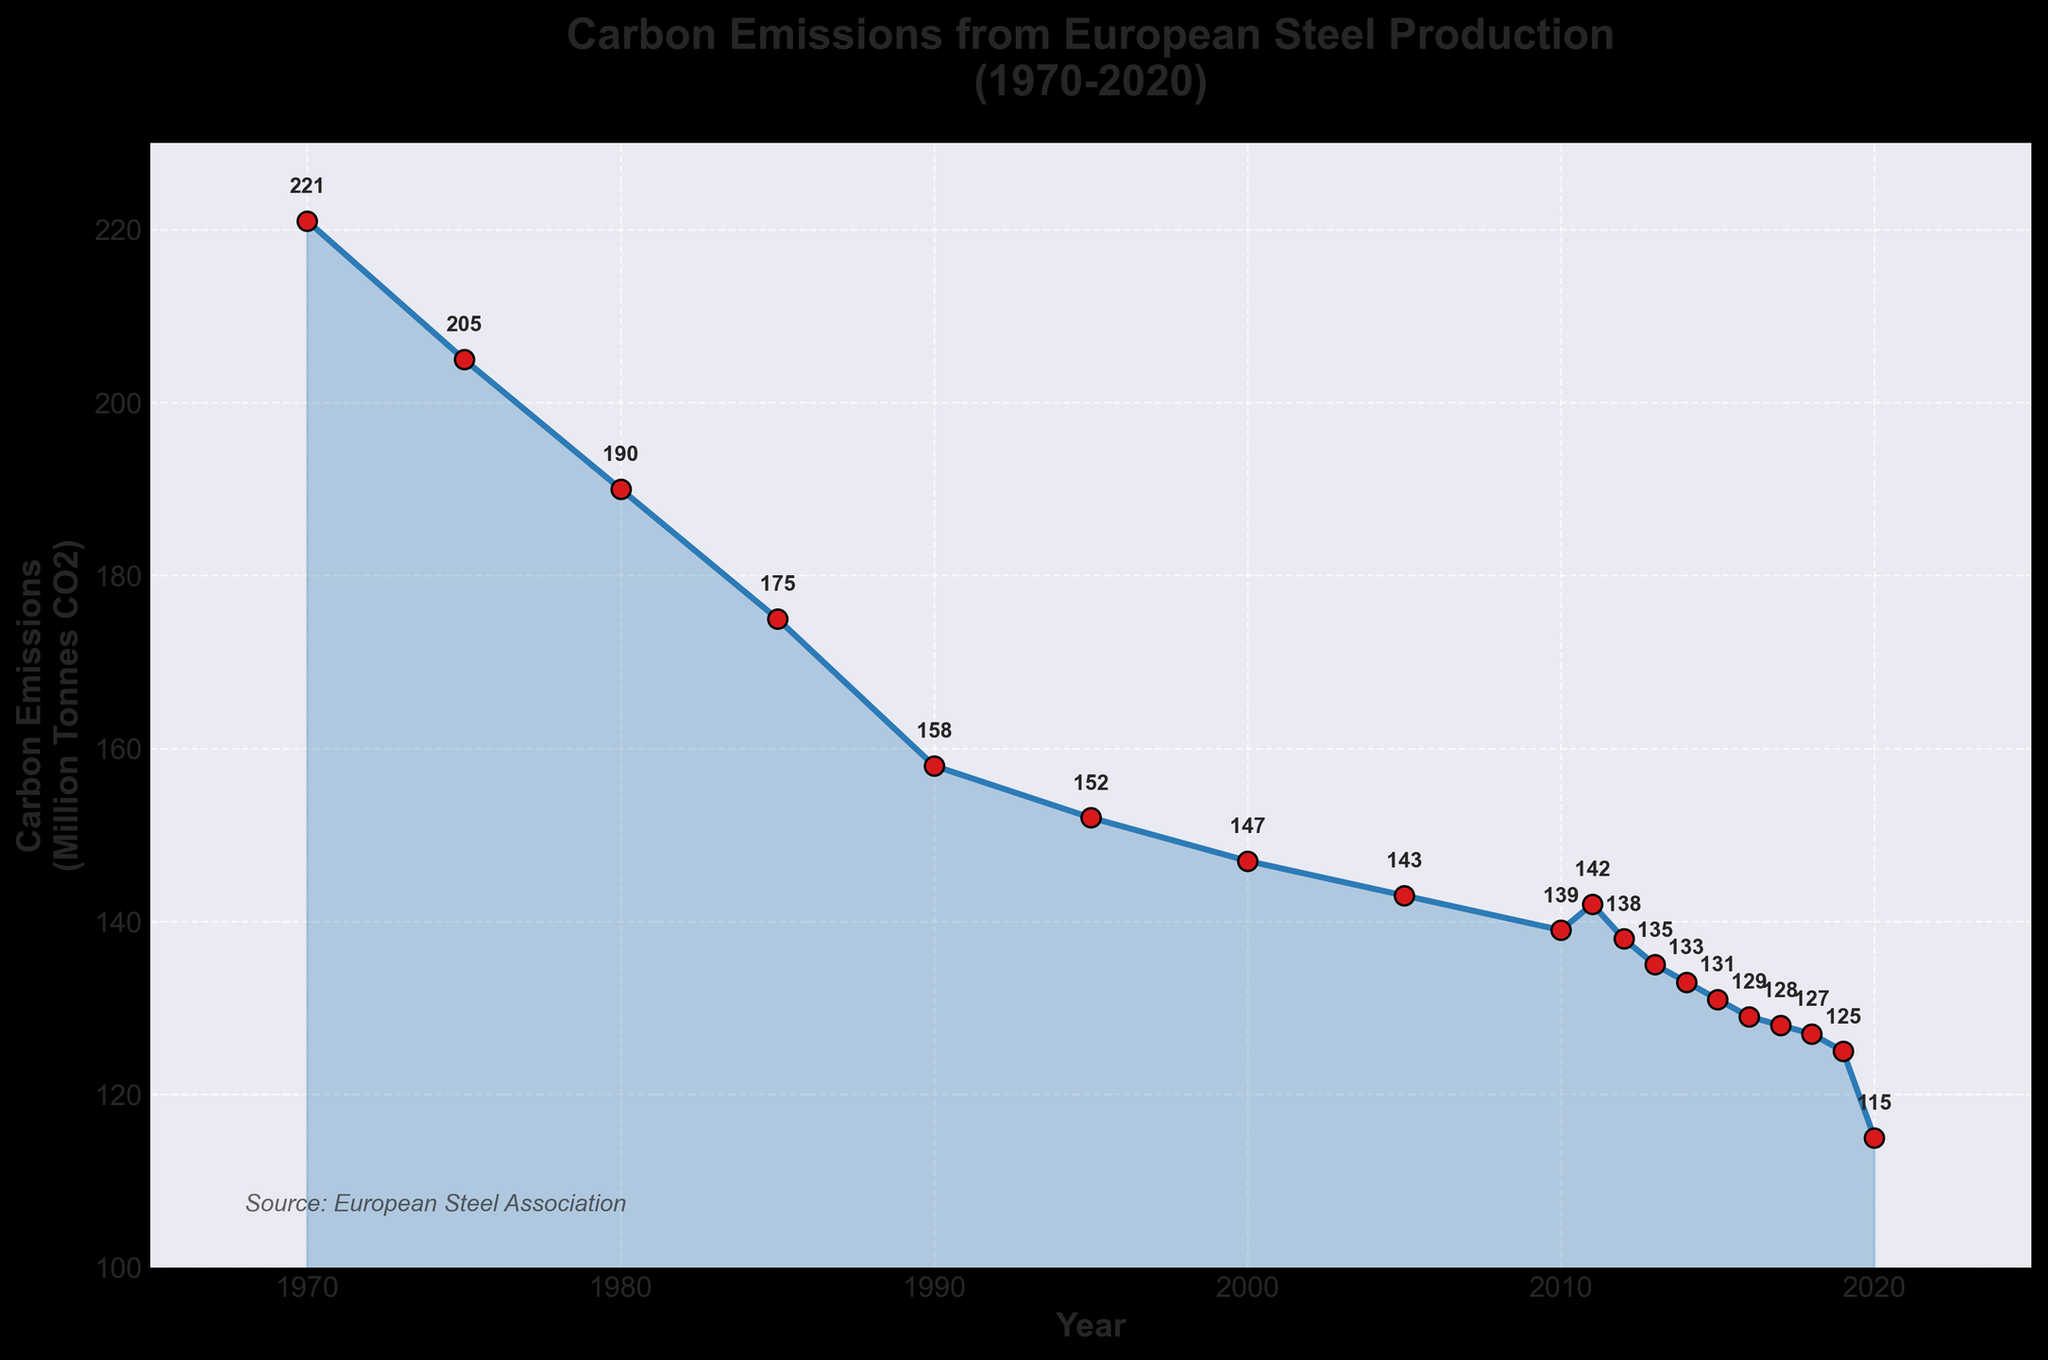What's the overall trend in carbon emissions from European steel production between 1970 and 2020? The overall trend shows a consistent decrease in carbon emissions from 221 million tonnes CO2 in 1970 to 115 million tonnes CO2 in 2020. This can be seen as the line on the chart slopes downwards over the years.
Answer: A consistent decrease What's the difference in carbon emissions between the years 1970 and 2020? To find the difference, subtract the carbon emissions in 2020 from the emissions in 1970. The emissions in 1970 are 221 million tonnes CO2, and in 2020, they are 115 million tonnes CO2. Therefore, the difference is 221 - 115 = 106 million tonnes CO2.
Answer: 106 million tonnes CO2 In which year were carbon emissions the lowest? The lowest point on the graph, which corresponds to the smallest value of carbon emissions, occurs in the year 2020 with 115 million tonnes CO2.
Answer: 2020 How did carbon emissions change between 1980 and 1985? To determine the change, note the emissions in 1980 (190 million tonnes CO2) and in 1985 (175 million tonnes CO2). The change is 190 - 175 = 15 million tonnes CO2, indicating a decrease.
Answer: Decreased by 15 million tonnes CO2 What is the average carbon emission from 2010 to 2020? To calculate the average, sum the emissions from 2010 to 2020 and divide by the number of years. The values are 139, 142, 138, 135, 133, 131, 129, 128, 127, 125, and 115, totaling 1342. There are 11 values, so the average is 1342 / 11 = 122 million tonnes CO2.
Answer: 122 million tonnes CO2 What can be inferred from the fluctuation in emissions between 2010 and 2012? Emissions slightly increased from 139 million tonnes CO2 in 2010 to 142 million tonnes CO2 in 2011, but then decreased again to 138 million tonnes CO2 in 2012. This indicates a small, temporary rise before returning to a downward trend.
Answer: A small temporary rise Which year experienced the sharpest drop in emissions and what was the magnitude of this drop? By visually inspecting the steepest downward segment of the graph, 2019 to 2020 shows the sharpest drop. Emissions went from 125 million tonnes CO2 in 2019 to 115 million tonnes CO2 in 2020. The magnitude of this drop is 125 - 115 = 10 million tonnes CO2.
Answer: 2019 to 2020, 10 million tonnes CO2 Compare carbon emissions in 1975 and 1995. How much did emissions decrease in these 20 years? Emissions in 1975 were 205 million tonnes CO2 and in 1995 were 152 million tonnes CO2. The decrease over these 20 years is 205 - 152 = 53 million tonnes CO2.
Answer: Decreased by 53 million tonnes CO2 What visual design elements are used to highlight the trend in emissions over the years? The graph uses a blue line with red markers to plot the annual data points, making the trend easy to follow. Additionally, it employs a shaded area below the line to visually emphasize the declining trend over the years. Text annotations for each data point also aid in identifying specific values.
Answer: Blue line with red markers, shaded area, text annotations Is there any year where carbon emissions increased from the previous year? Yes, there is one instance where emissions increased from the previous year. This occurs between 2010 and 2011, where emissions rose from 139 million tonnes CO2 to 142 million tonnes CO2.
Answer: 2010 to 2011 